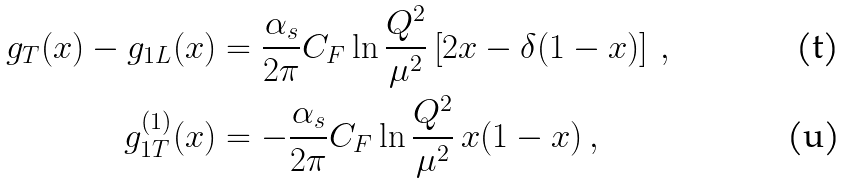<formula> <loc_0><loc_0><loc_500><loc_500>g _ { T } ( x ) - g _ { 1 L } ( x ) & = \frac { \alpha _ { s } } { 2 \pi } C _ { F } \ln { \frac { Q ^ { 2 } } { \mu ^ { 2 } } } \left [ 2 x - \delta ( 1 - x ) \right ] \, , \\ g _ { 1 T } ^ { ( 1 ) } ( x ) & = - \frac { \alpha _ { s } } { 2 \pi } C _ { F } \ln { \frac { Q ^ { 2 } } { \mu ^ { 2 } } } \, x ( 1 - x ) \, ,</formula> 